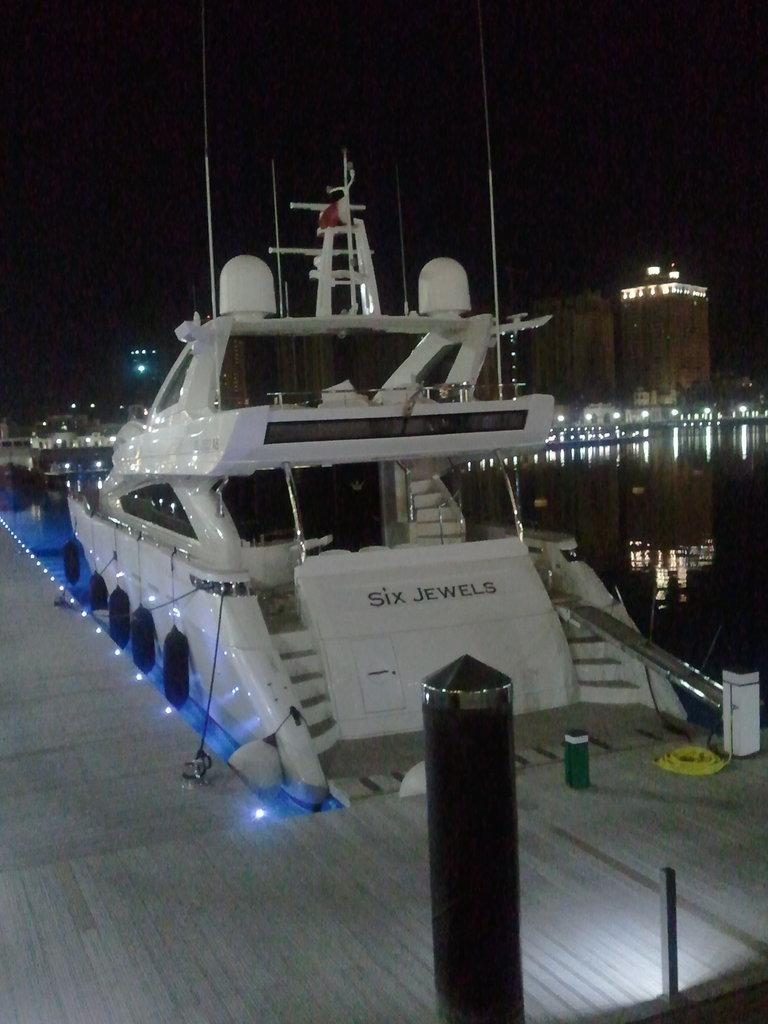In one or two sentences, can you explain what this image depicts? In this image, in the middle, we can see a black color pole and a boat which is drowning in the water. On the left side, we can see a floor. On the right side, we can see some poles, water which is in black color. In the background, we can see a building, tower and black color. In the background, we can also see a few lights. 